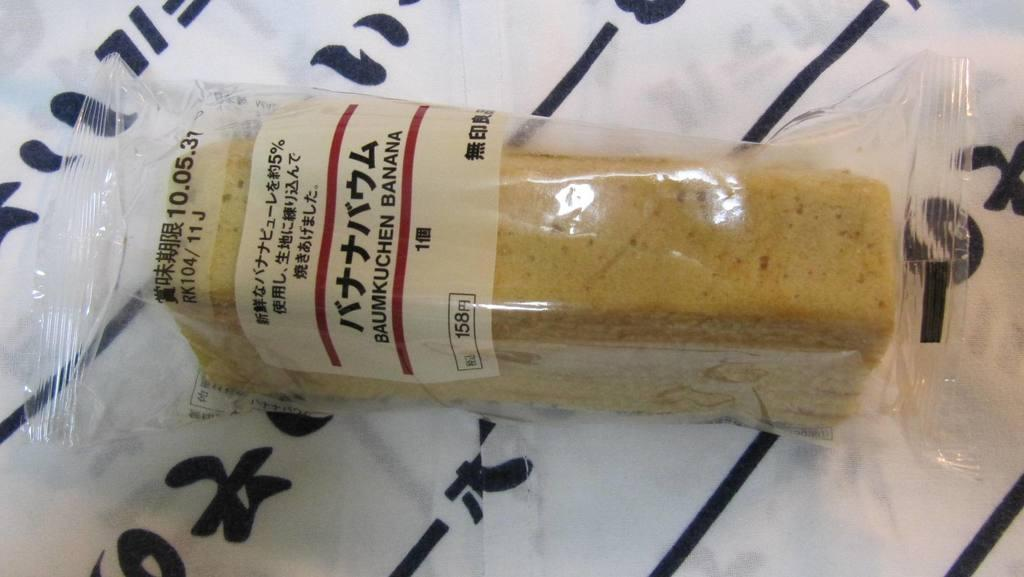Provide a one-sentence caption for the provided image. a desert wrapped in plastic that reads : baumkuchen banana. 